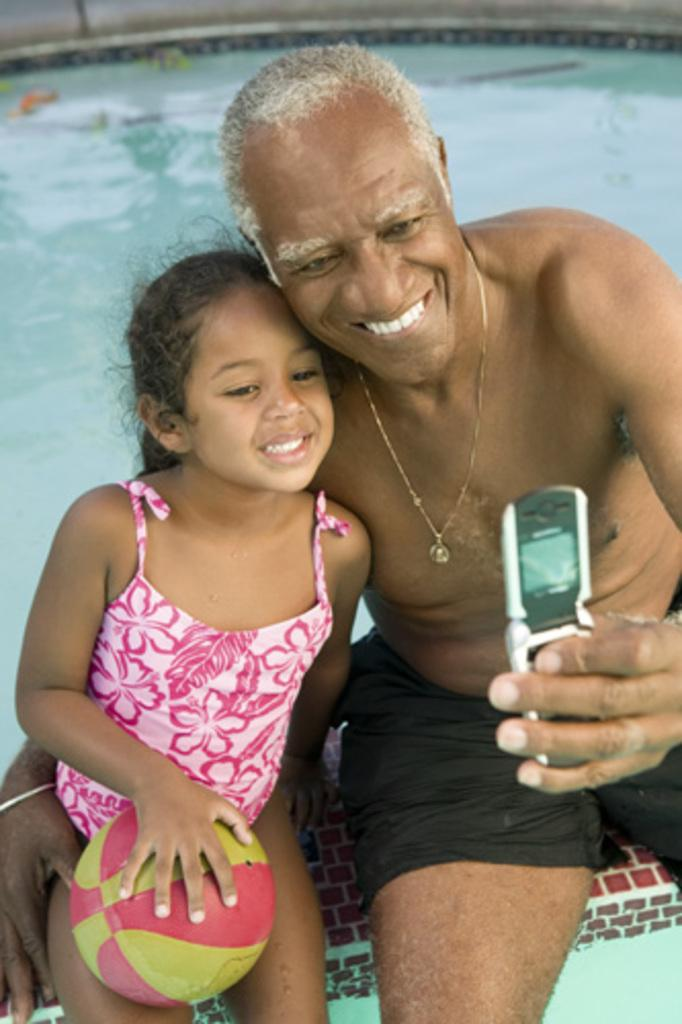Who is present in the image? There is a man and a girl in the image. What is the man holding in the image? The man is holding a mobile in the image. What is the man's facial expression? The man is smiling in the image. What is the girl doing in the image? The girl is sitting with a ball in the image. What can be seen in the background of the image? Water is visible in the background of the image. What type of health competition is the man participating in the image? There is no health competition present in the image. What material is used to cover the girl in the image? There is no indication of any cover or clothing on the girl in the image; she is simply sitting with a ball. 